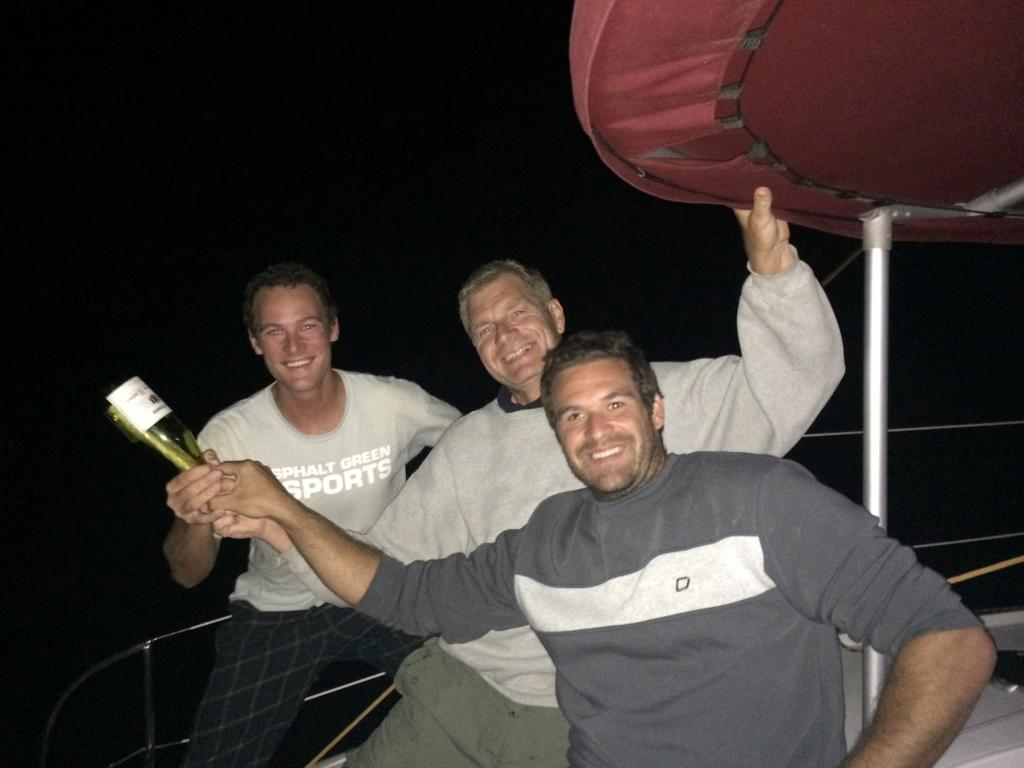How many people are in the image? There are three men in the image. What are the men doing in the image? The men are standing and smiling. What are the men holding in their hands? Each man is holding a bottle, and the middle man is holding a red-colored object. Where are the men located in the image? The men are on a boat. What is the men's theory about the coat in the image? There is no coat present in the image, so the men cannot have a theory about it. 